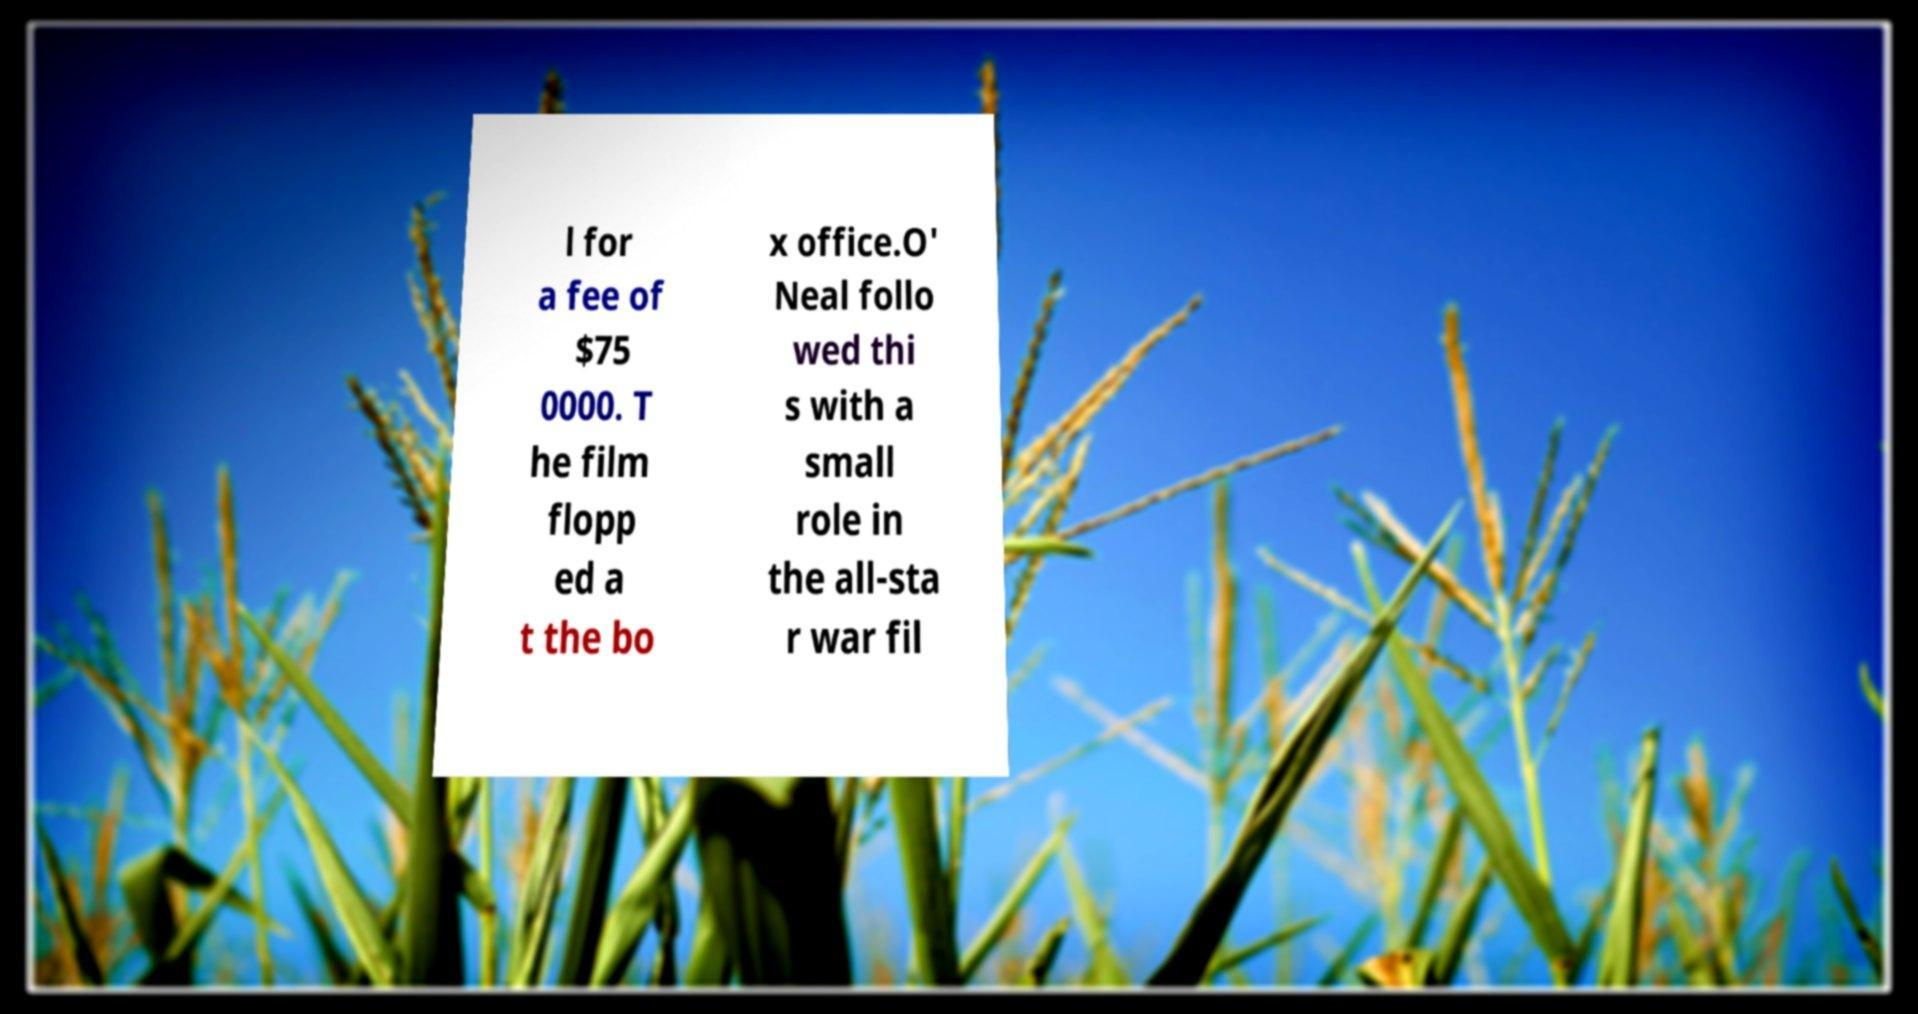I need the written content from this picture converted into text. Can you do that? l for a fee of $75 0000. T he film flopp ed a t the bo x office.O' Neal follo wed thi s with a small role in the all-sta r war fil 